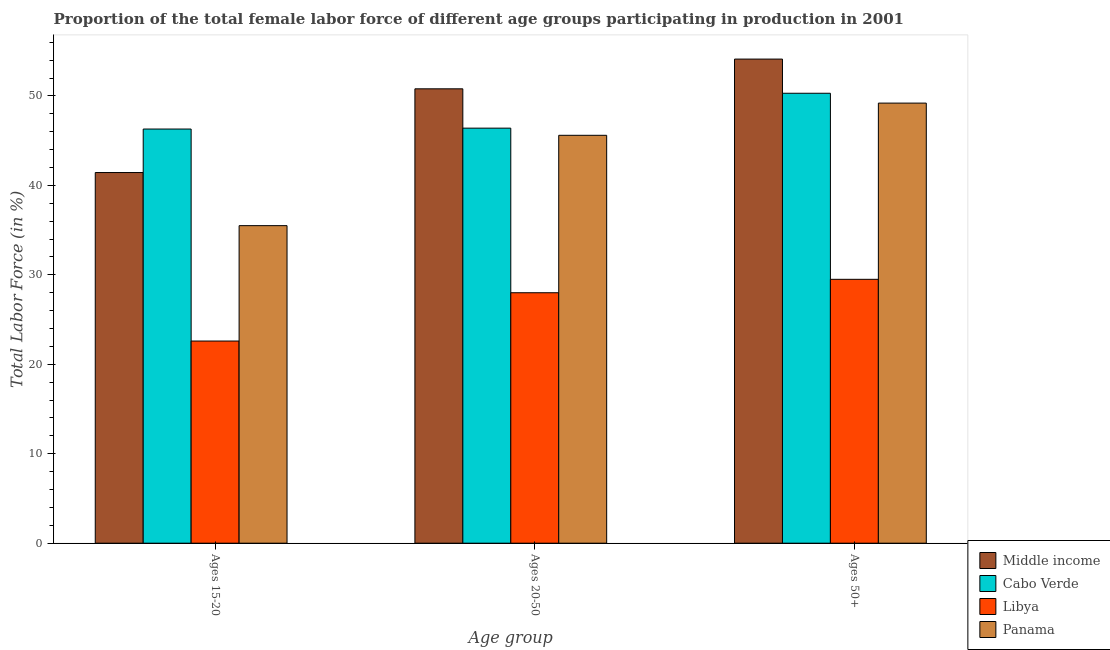How many groups of bars are there?
Give a very brief answer. 3. Are the number of bars on each tick of the X-axis equal?
Your response must be concise. Yes. How many bars are there on the 1st tick from the right?
Keep it short and to the point. 4. What is the label of the 2nd group of bars from the left?
Your answer should be very brief. Ages 20-50. What is the percentage of female labor force within the age group 15-20 in Libya?
Give a very brief answer. 22.6. Across all countries, what is the maximum percentage of female labor force above age 50?
Ensure brevity in your answer.  54.12. Across all countries, what is the minimum percentage of female labor force within the age group 15-20?
Give a very brief answer. 22.6. In which country was the percentage of female labor force within the age group 20-50 minimum?
Make the answer very short. Libya. What is the total percentage of female labor force above age 50 in the graph?
Provide a succinct answer. 183.12. What is the difference between the percentage of female labor force within the age group 15-20 in Cabo Verde and that in Middle income?
Ensure brevity in your answer.  4.86. What is the difference between the percentage of female labor force above age 50 in Middle income and the percentage of female labor force within the age group 15-20 in Cabo Verde?
Keep it short and to the point. 7.82. What is the average percentage of female labor force within the age group 15-20 per country?
Your answer should be compact. 36.46. What is the difference between the percentage of female labor force within the age group 20-50 and percentage of female labor force within the age group 15-20 in Panama?
Offer a terse response. 10.1. What is the ratio of the percentage of female labor force within the age group 15-20 in Middle income to that in Cabo Verde?
Give a very brief answer. 0.89. Is the percentage of female labor force within the age group 20-50 in Libya less than that in Panama?
Make the answer very short. Yes. Is the difference between the percentage of female labor force above age 50 in Panama and Libya greater than the difference between the percentage of female labor force within the age group 20-50 in Panama and Libya?
Your response must be concise. Yes. What is the difference between the highest and the second highest percentage of female labor force above age 50?
Your answer should be very brief. 3.82. What is the difference between the highest and the lowest percentage of female labor force above age 50?
Keep it short and to the point. 24.62. Is the sum of the percentage of female labor force within the age group 20-50 in Cabo Verde and Libya greater than the maximum percentage of female labor force within the age group 15-20 across all countries?
Provide a short and direct response. Yes. What does the 1st bar from the left in Ages 50+ represents?
Provide a short and direct response. Middle income. What does the 3rd bar from the right in Ages 20-50 represents?
Your answer should be very brief. Cabo Verde. Are all the bars in the graph horizontal?
Provide a succinct answer. No. How many countries are there in the graph?
Give a very brief answer. 4. What is the difference between two consecutive major ticks on the Y-axis?
Provide a succinct answer. 10. Are the values on the major ticks of Y-axis written in scientific E-notation?
Offer a very short reply. No. Does the graph contain grids?
Keep it short and to the point. No. How many legend labels are there?
Give a very brief answer. 4. How are the legend labels stacked?
Offer a very short reply. Vertical. What is the title of the graph?
Keep it short and to the point. Proportion of the total female labor force of different age groups participating in production in 2001. What is the label or title of the X-axis?
Ensure brevity in your answer.  Age group. What is the Total Labor Force (in %) of Middle income in Ages 15-20?
Provide a succinct answer. 41.44. What is the Total Labor Force (in %) in Cabo Verde in Ages 15-20?
Provide a short and direct response. 46.3. What is the Total Labor Force (in %) of Libya in Ages 15-20?
Make the answer very short. 22.6. What is the Total Labor Force (in %) of Panama in Ages 15-20?
Provide a short and direct response. 35.5. What is the Total Labor Force (in %) in Middle income in Ages 20-50?
Keep it short and to the point. 50.8. What is the Total Labor Force (in %) in Cabo Verde in Ages 20-50?
Give a very brief answer. 46.4. What is the Total Labor Force (in %) in Libya in Ages 20-50?
Your answer should be compact. 28. What is the Total Labor Force (in %) in Panama in Ages 20-50?
Your response must be concise. 45.6. What is the Total Labor Force (in %) in Middle income in Ages 50+?
Provide a short and direct response. 54.12. What is the Total Labor Force (in %) in Cabo Verde in Ages 50+?
Offer a terse response. 50.3. What is the Total Labor Force (in %) of Libya in Ages 50+?
Provide a short and direct response. 29.5. What is the Total Labor Force (in %) of Panama in Ages 50+?
Provide a short and direct response. 49.2. Across all Age group, what is the maximum Total Labor Force (in %) of Middle income?
Offer a very short reply. 54.12. Across all Age group, what is the maximum Total Labor Force (in %) in Cabo Verde?
Make the answer very short. 50.3. Across all Age group, what is the maximum Total Labor Force (in %) in Libya?
Give a very brief answer. 29.5. Across all Age group, what is the maximum Total Labor Force (in %) of Panama?
Offer a terse response. 49.2. Across all Age group, what is the minimum Total Labor Force (in %) of Middle income?
Your answer should be compact. 41.44. Across all Age group, what is the minimum Total Labor Force (in %) of Cabo Verde?
Offer a terse response. 46.3. Across all Age group, what is the minimum Total Labor Force (in %) of Libya?
Your answer should be compact. 22.6. Across all Age group, what is the minimum Total Labor Force (in %) in Panama?
Your answer should be compact. 35.5. What is the total Total Labor Force (in %) in Middle income in the graph?
Offer a very short reply. 146.36. What is the total Total Labor Force (in %) in Cabo Verde in the graph?
Ensure brevity in your answer.  143. What is the total Total Labor Force (in %) in Libya in the graph?
Keep it short and to the point. 80.1. What is the total Total Labor Force (in %) of Panama in the graph?
Provide a succinct answer. 130.3. What is the difference between the Total Labor Force (in %) of Middle income in Ages 15-20 and that in Ages 20-50?
Your answer should be very brief. -9.36. What is the difference between the Total Labor Force (in %) in Cabo Verde in Ages 15-20 and that in Ages 20-50?
Offer a very short reply. -0.1. What is the difference between the Total Labor Force (in %) in Middle income in Ages 15-20 and that in Ages 50+?
Your answer should be very brief. -12.68. What is the difference between the Total Labor Force (in %) of Libya in Ages 15-20 and that in Ages 50+?
Ensure brevity in your answer.  -6.9. What is the difference between the Total Labor Force (in %) in Panama in Ages 15-20 and that in Ages 50+?
Make the answer very short. -13.7. What is the difference between the Total Labor Force (in %) in Middle income in Ages 20-50 and that in Ages 50+?
Provide a succinct answer. -3.32. What is the difference between the Total Labor Force (in %) in Panama in Ages 20-50 and that in Ages 50+?
Provide a short and direct response. -3.6. What is the difference between the Total Labor Force (in %) in Middle income in Ages 15-20 and the Total Labor Force (in %) in Cabo Verde in Ages 20-50?
Your answer should be compact. -4.96. What is the difference between the Total Labor Force (in %) in Middle income in Ages 15-20 and the Total Labor Force (in %) in Libya in Ages 20-50?
Your response must be concise. 13.44. What is the difference between the Total Labor Force (in %) in Middle income in Ages 15-20 and the Total Labor Force (in %) in Panama in Ages 20-50?
Provide a succinct answer. -4.16. What is the difference between the Total Labor Force (in %) in Cabo Verde in Ages 15-20 and the Total Labor Force (in %) in Panama in Ages 20-50?
Make the answer very short. 0.7. What is the difference between the Total Labor Force (in %) of Middle income in Ages 15-20 and the Total Labor Force (in %) of Cabo Verde in Ages 50+?
Keep it short and to the point. -8.86. What is the difference between the Total Labor Force (in %) of Middle income in Ages 15-20 and the Total Labor Force (in %) of Libya in Ages 50+?
Keep it short and to the point. 11.94. What is the difference between the Total Labor Force (in %) of Middle income in Ages 15-20 and the Total Labor Force (in %) of Panama in Ages 50+?
Your answer should be very brief. -7.76. What is the difference between the Total Labor Force (in %) of Cabo Verde in Ages 15-20 and the Total Labor Force (in %) of Panama in Ages 50+?
Your response must be concise. -2.9. What is the difference between the Total Labor Force (in %) in Libya in Ages 15-20 and the Total Labor Force (in %) in Panama in Ages 50+?
Your answer should be very brief. -26.6. What is the difference between the Total Labor Force (in %) of Middle income in Ages 20-50 and the Total Labor Force (in %) of Cabo Verde in Ages 50+?
Provide a succinct answer. 0.5. What is the difference between the Total Labor Force (in %) in Middle income in Ages 20-50 and the Total Labor Force (in %) in Libya in Ages 50+?
Offer a terse response. 21.3. What is the difference between the Total Labor Force (in %) of Middle income in Ages 20-50 and the Total Labor Force (in %) of Panama in Ages 50+?
Your response must be concise. 1.6. What is the difference between the Total Labor Force (in %) in Libya in Ages 20-50 and the Total Labor Force (in %) in Panama in Ages 50+?
Keep it short and to the point. -21.2. What is the average Total Labor Force (in %) in Middle income per Age group?
Your answer should be very brief. 48.79. What is the average Total Labor Force (in %) of Cabo Verde per Age group?
Your answer should be compact. 47.67. What is the average Total Labor Force (in %) in Libya per Age group?
Ensure brevity in your answer.  26.7. What is the average Total Labor Force (in %) of Panama per Age group?
Provide a succinct answer. 43.43. What is the difference between the Total Labor Force (in %) in Middle income and Total Labor Force (in %) in Cabo Verde in Ages 15-20?
Ensure brevity in your answer.  -4.86. What is the difference between the Total Labor Force (in %) in Middle income and Total Labor Force (in %) in Libya in Ages 15-20?
Make the answer very short. 18.84. What is the difference between the Total Labor Force (in %) of Middle income and Total Labor Force (in %) of Panama in Ages 15-20?
Ensure brevity in your answer.  5.94. What is the difference between the Total Labor Force (in %) of Cabo Verde and Total Labor Force (in %) of Libya in Ages 15-20?
Your answer should be compact. 23.7. What is the difference between the Total Labor Force (in %) in Cabo Verde and Total Labor Force (in %) in Panama in Ages 15-20?
Provide a succinct answer. 10.8. What is the difference between the Total Labor Force (in %) in Middle income and Total Labor Force (in %) in Cabo Verde in Ages 20-50?
Your response must be concise. 4.4. What is the difference between the Total Labor Force (in %) in Middle income and Total Labor Force (in %) in Libya in Ages 20-50?
Your answer should be very brief. 22.8. What is the difference between the Total Labor Force (in %) in Middle income and Total Labor Force (in %) in Panama in Ages 20-50?
Give a very brief answer. 5.2. What is the difference between the Total Labor Force (in %) of Cabo Verde and Total Labor Force (in %) of Panama in Ages 20-50?
Your answer should be very brief. 0.8. What is the difference between the Total Labor Force (in %) in Libya and Total Labor Force (in %) in Panama in Ages 20-50?
Provide a short and direct response. -17.6. What is the difference between the Total Labor Force (in %) in Middle income and Total Labor Force (in %) in Cabo Verde in Ages 50+?
Your response must be concise. 3.82. What is the difference between the Total Labor Force (in %) of Middle income and Total Labor Force (in %) of Libya in Ages 50+?
Offer a very short reply. 24.62. What is the difference between the Total Labor Force (in %) in Middle income and Total Labor Force (in %) in Panama in Ages 50+?
Provide a succinct answer. 4.92. What is the difference between the Total Labor Force (in %) of Cabo Verde and Total Labor Force (in %) of Libya in Ages 50+?
Make the answer very short. 20.8. What is the difference between the Total Labor Force (in %) of Libya and Total Labor Force (in %) of Panama in Ages 50+?
Keep it short and to the point. -19.7. What is the ratio of the Total Labor Force (in %) of Middle income in Ages 15-20 to that in Ages 20-50?
Offer a very short reply. 0.82. What is the ratio of the Total Labor Force (in %) in Libya in Ages 15-20 to that in Ages 20-50?
Give a very brief answer. 0.81. What is the ratio of the Total Labor Force (in %) in Panama in Ages 15-20 to that in Ages 20-50?
Give a very brief answer. 0.78. What is the ratio of the Total Labor Force (in %) in Middle income in Ages 15-20 to that in Ages 50+?
Your answer should be compact. 0.77. What is the ratio of the Total Labor Force (in %) in Cabo Verde in Ages 15-20 to that in Ages 50+?
Make the answer very short. 0.92. What is the ratio of the Total Labor Force (in %) in Libya in Ages 15-20 to that in Ages 50+?
Provide a short and direct response. 0.77. What is the ratio of the Total Labor Force (in %) of Panama in Ages 15-20 to that in Ages 50+?
Offer a very short reply. 0.72. What is the ratio of the Total Labor Force (in %) in Middle income in Ages 20-50 to that in Ages 50+?
Offer a very short reply. 0.94. What is the ratio of the Total Labor Force (in %) in Cabo Verde in Ages 20-50 to that in Ages 50+?
Ensure brevity in your answer.  0.92. What is the ratio of the Total Labor Force (in %) in Libya in Ages 20-50 to that in Ages 50+?
Provide a short and direct response. 0.95. What is the ratio of the Total Labor Force (in %) in Panama in Ages 20-50 to that in Ages 50+?
Offer a terse response. 0.93. What is the difference between the highest and the second highest Total Labor Force (in %) in Middle income?
Make the answer very short. 3.32. What is the difference between the highest and the second highest Total Labor Force (in %) in Cabo Verde?
Offer a terse response. 3.9. What is the difference between the highest and the second highest Total Labor Force (in %) in Panama?
Offer a terse response. 3.6. What is the difference between the highest and the lowest Total Labor Force (in %) in Middle income?
Provide a succinct answer. 12.68. What is the difference between the highest and the lowest Total Labor Force (in %) in Panama?
Provide a short and direct response. 13.7. 